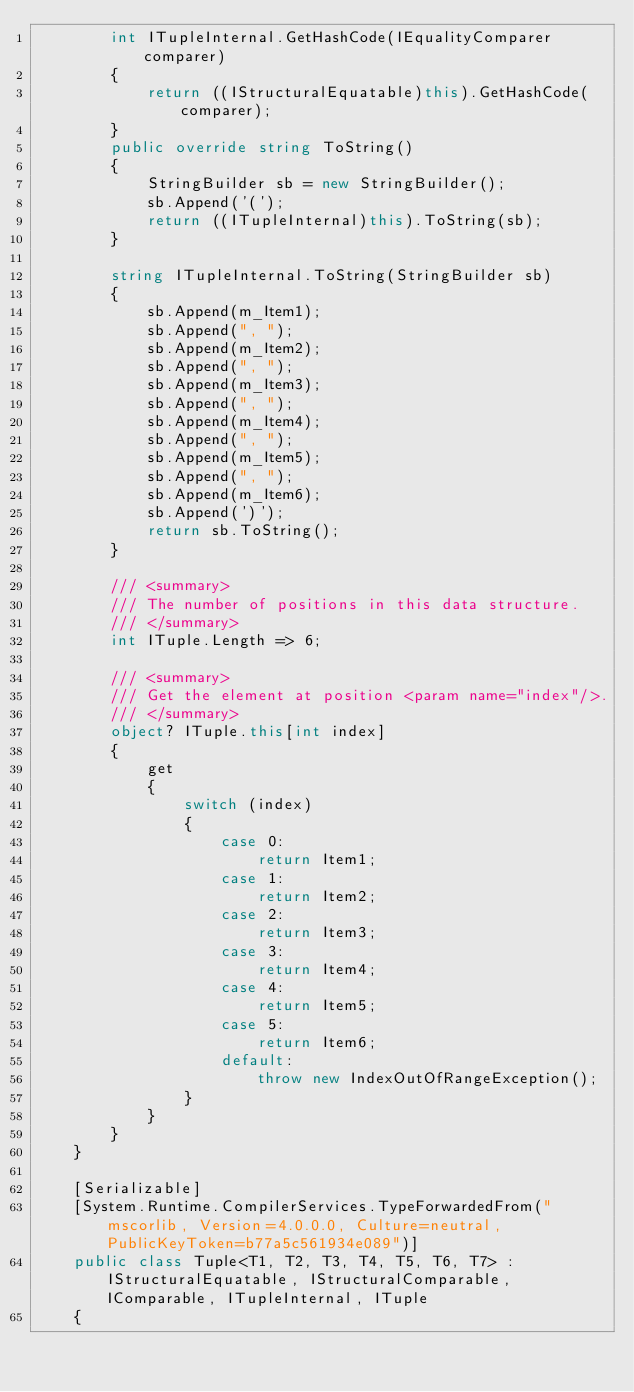Convert code to text. <code><loc_0><loc_0><loc_500><loc_500><_C#_>        int ITupleInternal.GetHashCode(IEqualityComparer comparer)
        {
            return ((IStructuralEquatable)this).GetHashCode(comparer);
        }
        public override string ToString()
        {
            StringBuilder sb = new StringBuilder();
            sb.Append('(');
            return ((ITupleInternal)this).ToString(sb);
        }

        string ITupleInternal.ToString(StringBuilder sb)
        {
            sb.Append(m_Item1);
            sb.Append(", ");
            sb.Append(m_Item2);
            sb.Append(", ");
            sb.Append(m_Item3);
            sb.Append(", ");
            sb.Append(m_Item4);
            sb.Append(", ");
            sb.Append(m_Item5);
            sb.Append(", ");
            sb.Append(m_Item6);
            sb.Append(')');
            return sb.ToString();
        }

        /// <summary>
        /// The number of positions in this data structure.
        /// </summary>
        int ITuple.Length => 6;

        /// <summary>
        /// Get the element at position <param name="index"/>.
        /// </summary>
        object? ITuple.this[int index]
        {
            get
            {
                switch (index)
                {
                    case 0:
                        return Item1;
                    case 1:
                        return Item2;
                    case 2:
                        return Item3;
                    case 3:
                        return Item4;
                    case 4:
                        return Item5;
                    case 5:
                        return Item6;
                    default:
                        throw new IndexOutOfRangeException();
                }
            }
        }
    }

    [Serializable]
    [System.Runtime.CompilerServices.TypeForwardedFrom("mscorlib, Version=4.0.0.0, Culture=neutral, PublicKeyToken=b77a5c561934e089")]
    public class Tuple<T1, T2, T3, T4, T5, T6, T7> : IStructuralEquatable, IStructuralComparable, IComparable, ITupleInternal, ITuple
    {</code> 